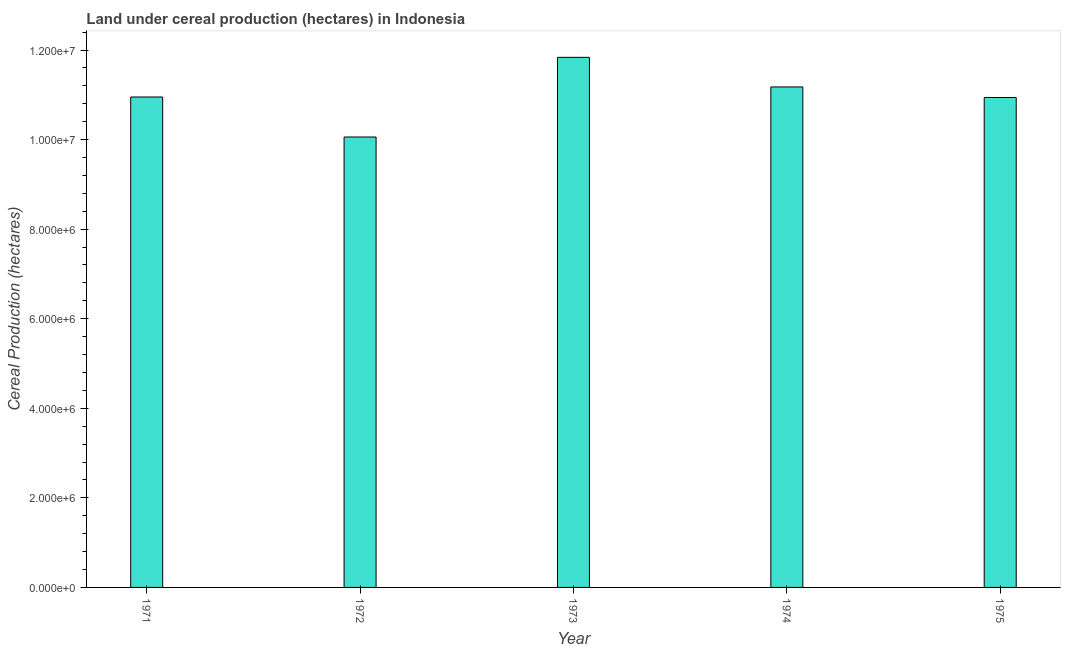Does the graph contain grids?
Offer a terse response. No. What is the title of the graph?
Your answer should be very brief. Land under cereal production (hectares) in Indonesia. What is the label or title of the Y-axis?
Give a very brief answer. Cereal Production (hectares). What is the land under cereal production in 1973?
Offer a very short reply. 1.18e+07. Across all years, what is the maximum land under cereal production?
Your answer should be compact. 1.18e+07. Across all years, what is the minimum land under cereal production?
Offer a terse response. 1.01e+07. In which year was the land under cereal production maximum?
Offer a terse response. 1973. What is the sum of the land under cereal production?
Offer a terse response. 5.50e+07. What is the difference between the land under cereal production in 1974 and 1975?
Keep it short and to the point. 2.36e+05. What is the average land under cereal production per year?
Offer a very short reply. 1.10e+07. What is the median land under cereal production?
Offer a very short reply. 1.10e+07. In how many years, is the land under cereal production greater than 10800000 hectares?
Provide a short and direct response. 4. Do a majority of the years between 1973 and 1972 (inclusive) have land under cereal production greater than 9200000 hectares?
Your answer should be compact. No. What is the ratio of the land under cereal production in 1974 to that in 1975?
Make the answer very short. 1.02. Is the land under cereal production in 1973 less than that in 1975?
Provide a succinct answer. No. What is the difference between the highest and the second highest land under cereal production?
Ensure brevity in your answer.  6.61e+05. Is the sum of the land under cereal production in 1973 and 1974 greater than the maximum land under cereal production across all years?
Make the answer very short. Yes. What is the difference between the highest and the lowest land under cereal production?
Ensure brevity in your answer.  1.78e+06. Are all the bars in the graph horizontal?
Give a very brief answer. No. Are the values on the major ticks of Y-axis written in scientific E-notation?
Your response must be concise. Yes. What is the Cereal Production (hectares) of 1971?
Give a very brief answer. 1.10e+07. What is the Cereal Production (hectares) of 1972?
Provide a succinct answer. 1.01e+07. What is the Cereal Production (hectares) of 1973?
Your answer should be very brief. 1.18e+07. What is the Cereal Production (hectares) of 1974?
Provide a short and direct response. 1.12e+07. What is the Cereal Production (hectares) of 1975?
Give a very brief answer. 1.09e+07. What is the difference between the Cereal Production (hectares) in 1971 and 1972?
Ensure brevity in your answer.  8.93e+05. What is the difference between the Cereal Production (hectares) in 1971 and 1973?
Provide a short and direct response. -8.86e+05. What is the difference between the Cereal Production (hectares) in 1971 and 1974?
Offer a terse response. -2.24e+05. What is the difference between the Cereal Production (hectares) in 1971 and 1975?
Offer a terse response. 1.10e+04. What is the difference between the Cereal Production (hectares) in 1972 and 1973?
Your answer should be compact. -1.78e+06. What is the difference between the Cereal Production (hectares) in 1972 and 1974?
Ensure brevity in your answer.  -1.12e+06. What is the difference between the Cereal Production (hectares) in 1972 and 1975?
Ensure brevity in your answer.  -8.82e+05. What is the difference between the Cereal Production (hectares) in 1973 and 1974?
Your answer should be very brief. 6.61e+05. What is the difference between the Cereal Production (hectares) in 1973 and 1975?
Offer a very short reply. 8.97e+05. What is the difference between the Cereal Production (hectares) in 1974 and 1975?
Make the answer very short. 2.36e+05. What is the ratio of the Cereal Production (hectares) in 1971 to that in 1972?
Your response must be concise. 1.09. What is the ratio of the Cereal Production (hectares) in 1971 to that in 1973?
Keep it short and to the point. 0.93. What is the ratio of the Cereal Production (hectares) in 1971 to that in 1974?
Make the answer very short. 0.98. What is the ratio of the Cereal Production (hectares) in 1971 to that in 1975?
Provide a succinct answer. 1. What is the ratio of the Cereal Production (hectares) in 1972 to that in 1973?
Provide a short and direct response. 0.85. What is the ratio of the Cereal Production (hectares) in 1972 to that in 1974?
Offer a very short reply. 0.9. What is the ratio of the Cereal Production (hectares) in 1972 to that in 1975?
Give a very brief answer. 0.92. What is the ratio of the Cereal Production (hectares) in 1973 to that in 1974?
Your response must be concise. 1.06. What is the ratio of the Cereal Production (hectares) in 1973 to that in 1975?
Provide a short and direct response. 1.08. What is the ratio of the Cereal Production (hectares) in 1974 to that in 1975?
Keep it short and to the point. 1.02. 